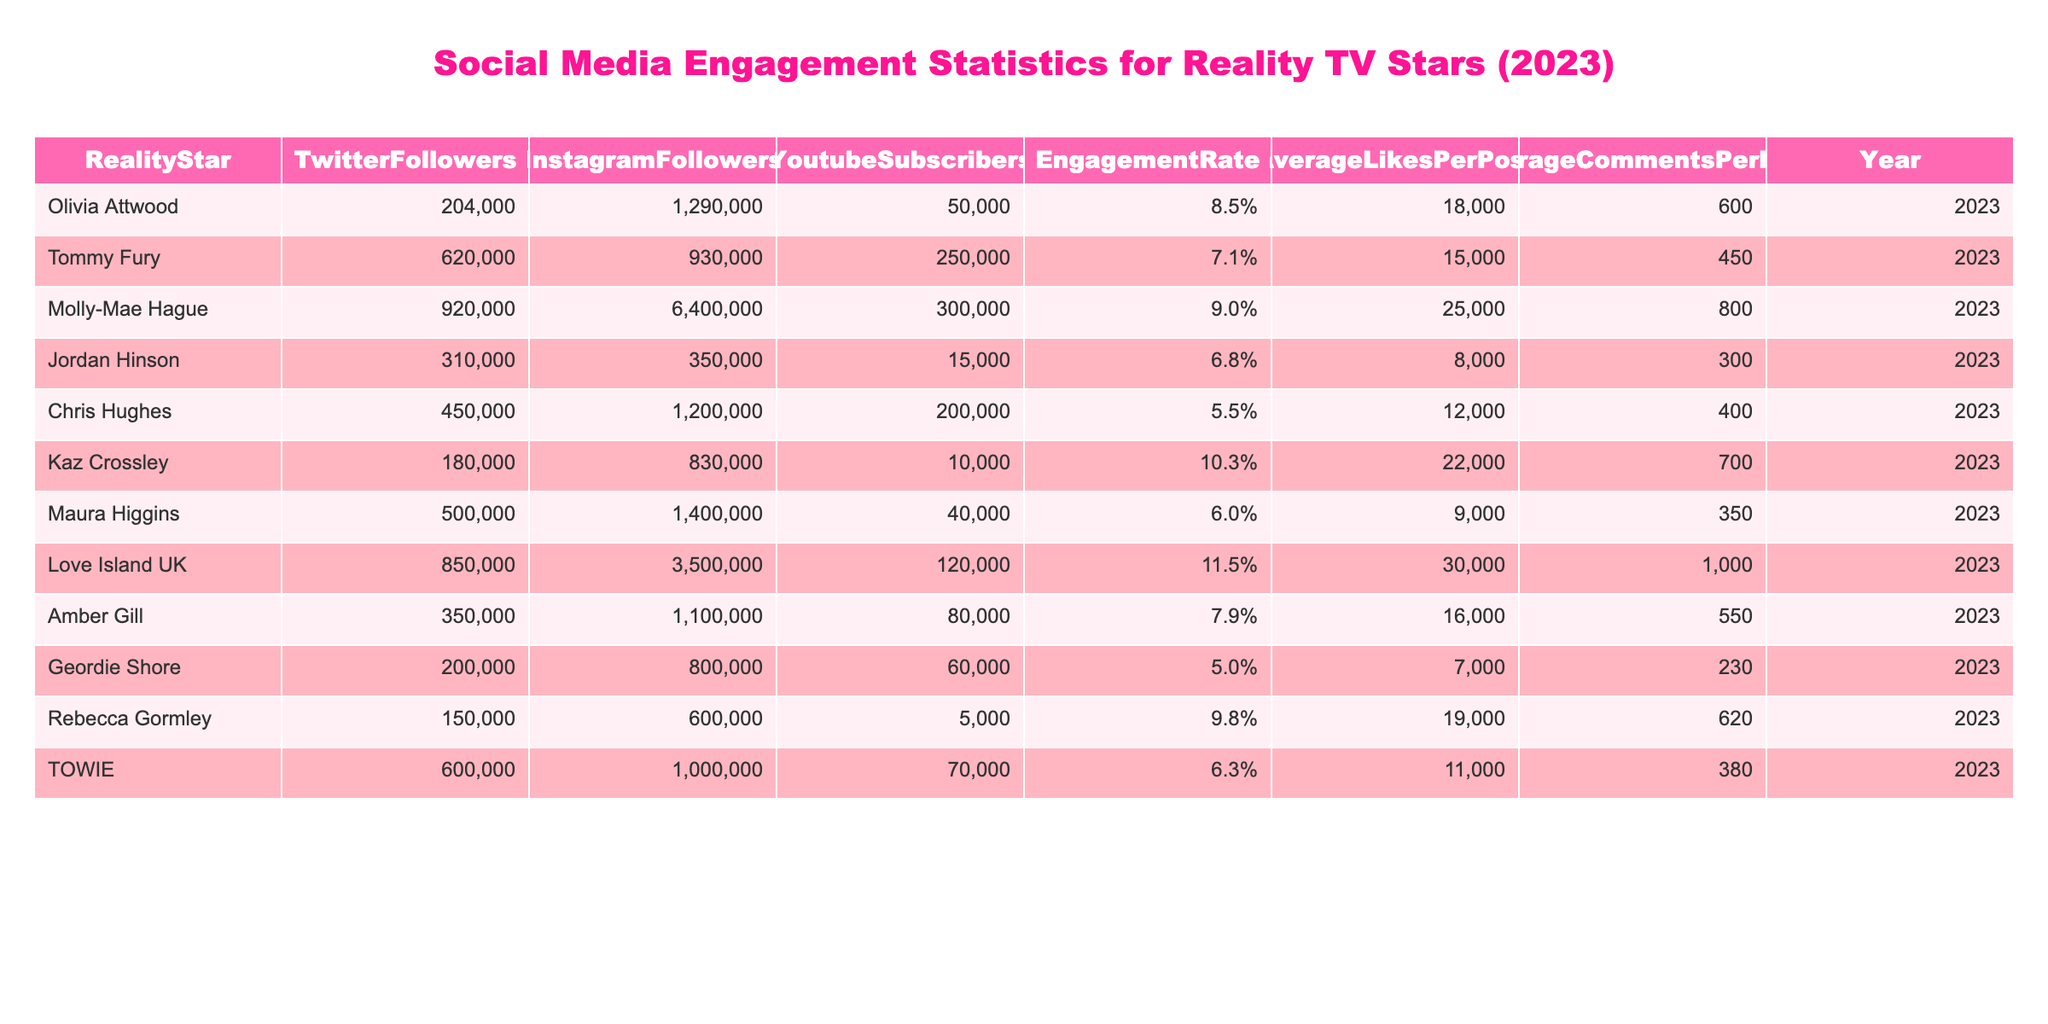What is the Engagement Rate of Olivia Attwood? To find the Engagement Rate of Olivia Attwood, I look at her row in the table where the Engagement Rate is listed as 8.5%.
Answer: 8.5% Who has the highest number of Instagram Followers? By examining the Instagram Followers column, I see that Molly-Mae Hague has the highest count with 6,400,000 followers.
Answer: Molly-Mae Hague Which reality star has the lowest Average Likes Per Post? Looking at the Average Likes Per Post column, I see that Maura Higgins has the lowest with 9,000 likes per post.
Answer: Maura Higgins Is Chris Hughes’s Engagement Rate higher than Tommy Fury's? I compare the Engagement Rates: Chris Hughes is at 5.5% and Tommy Fury is at 7.1%. Since 5.5% is less than 7.1%, the answer is no.
Answer: No What is the total number of Twitter Followers for all reality stars? I add the Twitter Followers for each star: 204000 + 620000 + 920000 + 310000 + 450000 + 180000 + 500000 + 850000 + 350000 + 200000 + 150000 + 600000 = 4,924,000.
Answer: 4,924,000 Is Love Island UK among the top three stars with the highest Engagement Rate? The Engagement Rates are: Love Island UK (11.5%), Kaz Crossley (10.3%), Molly-Mae Hague (9.0%), and others less than those three. It confirms that Love Island UK is indeed in the top three.
Answer: Yes What is the difference in Average Comments Per Post between Kaz Crossley and Rebecca Gormley? I find the Average Comments Per Post: Kaz Crossley (700) and Rebecca Gormley (620). The difference is 700 - 620 = 80.
Answer: 80 What is the average number of Youtube Subscribers among all reality stars? I sum the Youtube Subscribers: 50000 + 250000 + 300000 + 15000 + 200000 + 10000 + 40000 + 120000 + 80000 + 60000 + 5000 + 70000 = 1,389,000. Then, I have 12 data points for the average: 1,389,000 / 12 = 115,750.
Answer: 115,750 Which reality star has both the highest Engagement Rate and Average Likes Per Post? I evaluate the highest Engagement Rates and Average Likes Per Post together: Love Island UK has the highest Engagement Rate (11.5%) but only 30,000 Average Likes. For the highest Average Likes per Post, Molly-Mae Hague at 25,000 has a lower Engagement Rate. Thus, no single star leads in both categories.
Answer: No single star Who has more than 200,000 in Twitter Followers and an Engagement Rate above 8%? I filter the table for Twitter Followers > 200,000 and Engagement Rate > 8%. The stars are Olivia Attwood (8.5%), Molly-Mae Hague (9.0%), Kaz Crossley (10.3%), and Love Island UK (11.5%).
Answer: Olivia Attwood, Molly-Mae Hague, Kaz Crossley, Love Island UK 